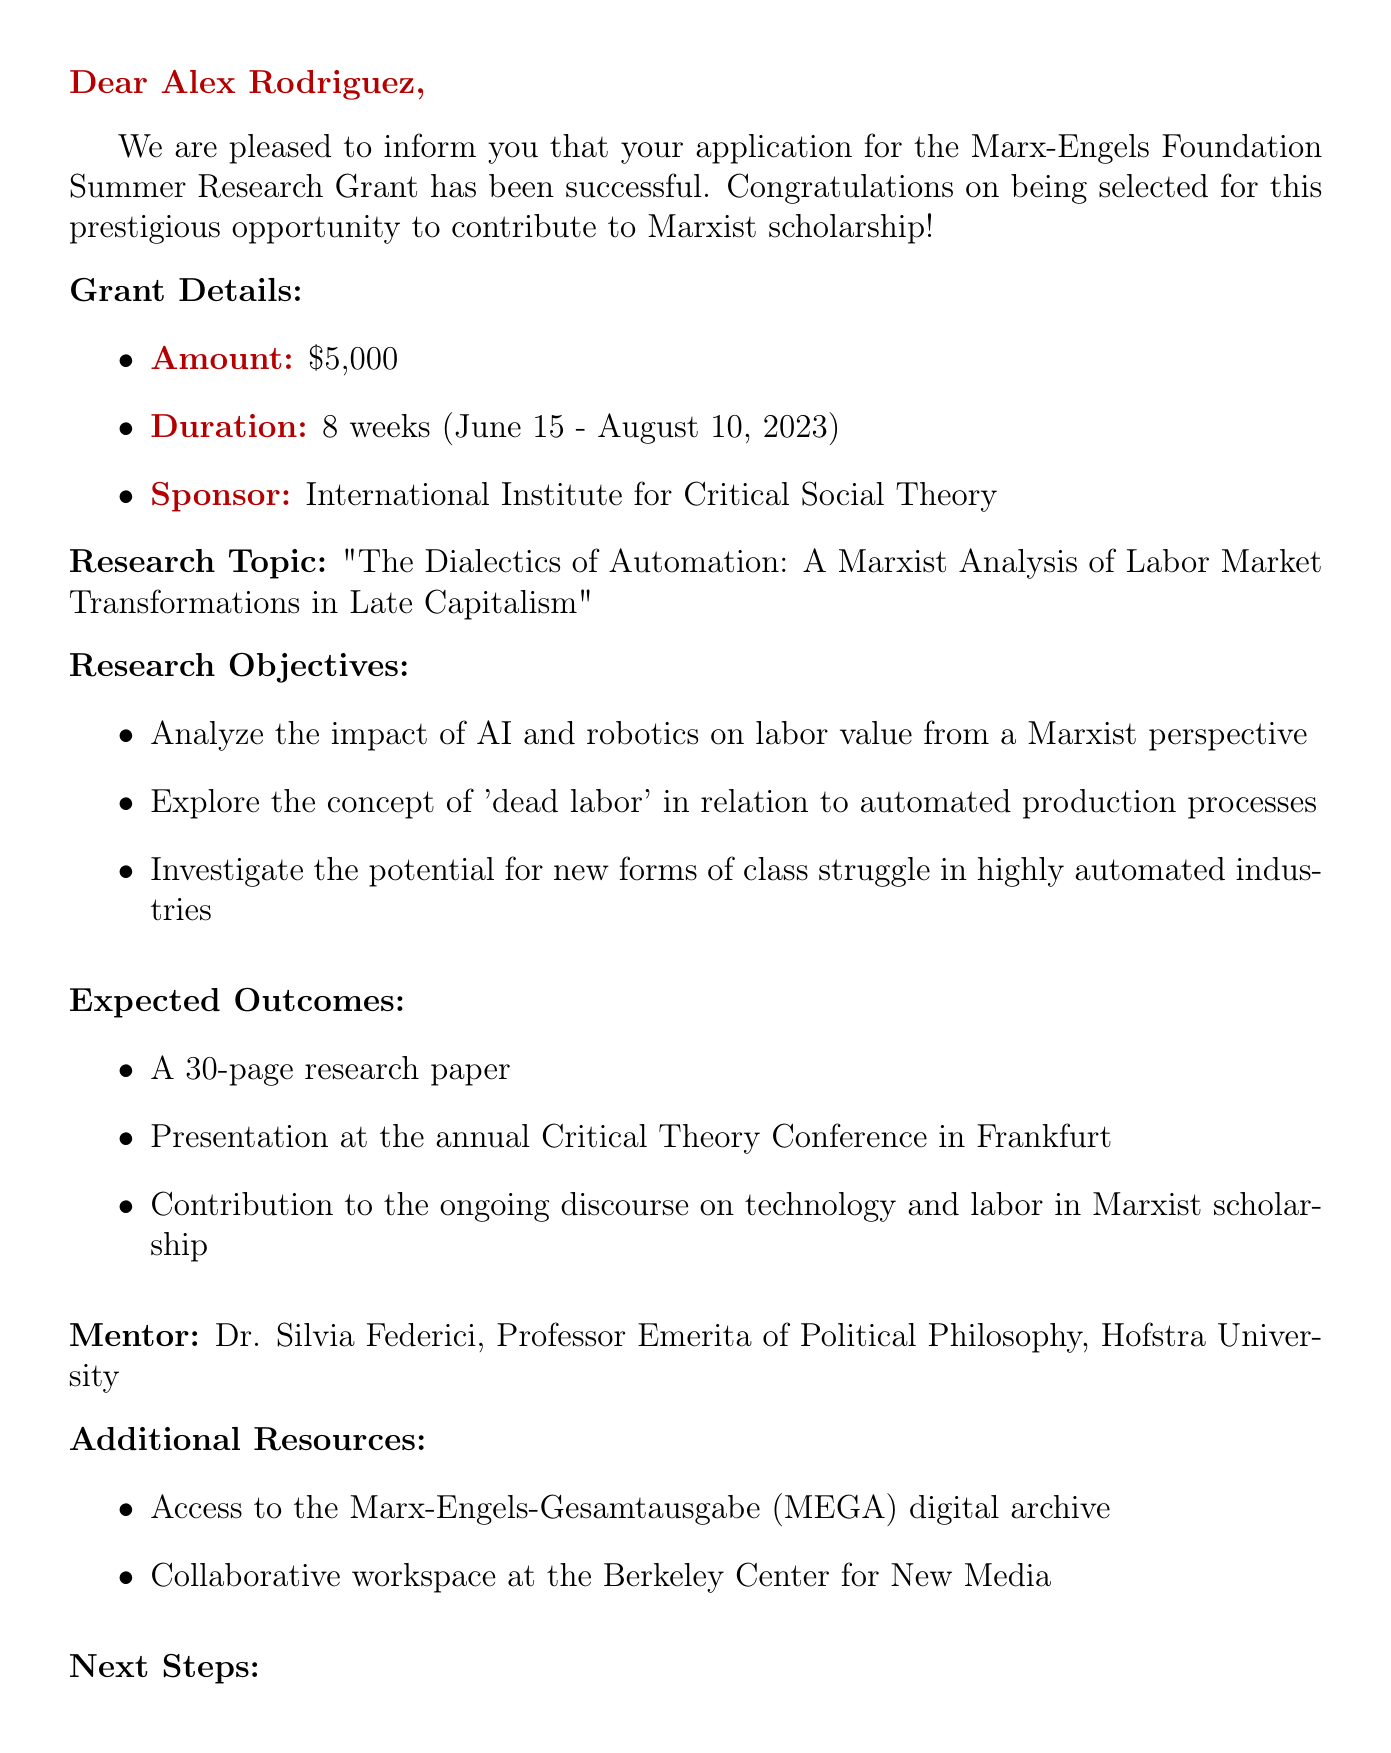What is the name of the grant? The name of the grant is explicitly stated in the document as "Marx-Engels Foundation Summer Research Grant."
Answer: Marx-Engels Foundation Summer Research Grant What is the grant amount? The document specifies that the amount awarded for the grant is $5,000.
Answer: $5,000 Who is the mentor for the research? The document identifies Dr. Silvia Federici as the mentor for the research project.
Answer: Dr. Silvia Federici What are the research objectives? The document outlines three specific research objectives that discuss the impact of automation, dead labor, and class struggle.
Answer: Analyze the impact of AI and robotics on labor value from a Marxist perspective What is the duration of the grant? The duration of the grant is mentioned in the document as 8 weeks, from June 15 to August 10, 2023.
Answer: 8 weeks (June 15 - August 10, 2023) When is the initial meeting with the mentor scheduled? The document states that the initial meeting with Dr. Federici should be scheduled but does not specify a date; however, it indicates the next steps to complete by May 1, 2023.
Answer: May 1, 2023 What is one expected outcome of the research? The document lists expected outcomes, including a 30-page research paper, among others.
Answer: A 30-page research paper What session must be attended before the research starts? The document indicates that a pre-research orientation session is to be attended on June 1, 2023.
Answer: June 1, 2023 What resource is available for archival research? The document mentions access to the Marx-Engels-Gesamtausgabe (MEGA) digital archive as an additional resource for the research.
Answer: Marx-Engels-Gesamtausgabe (MEGA) digital archive 